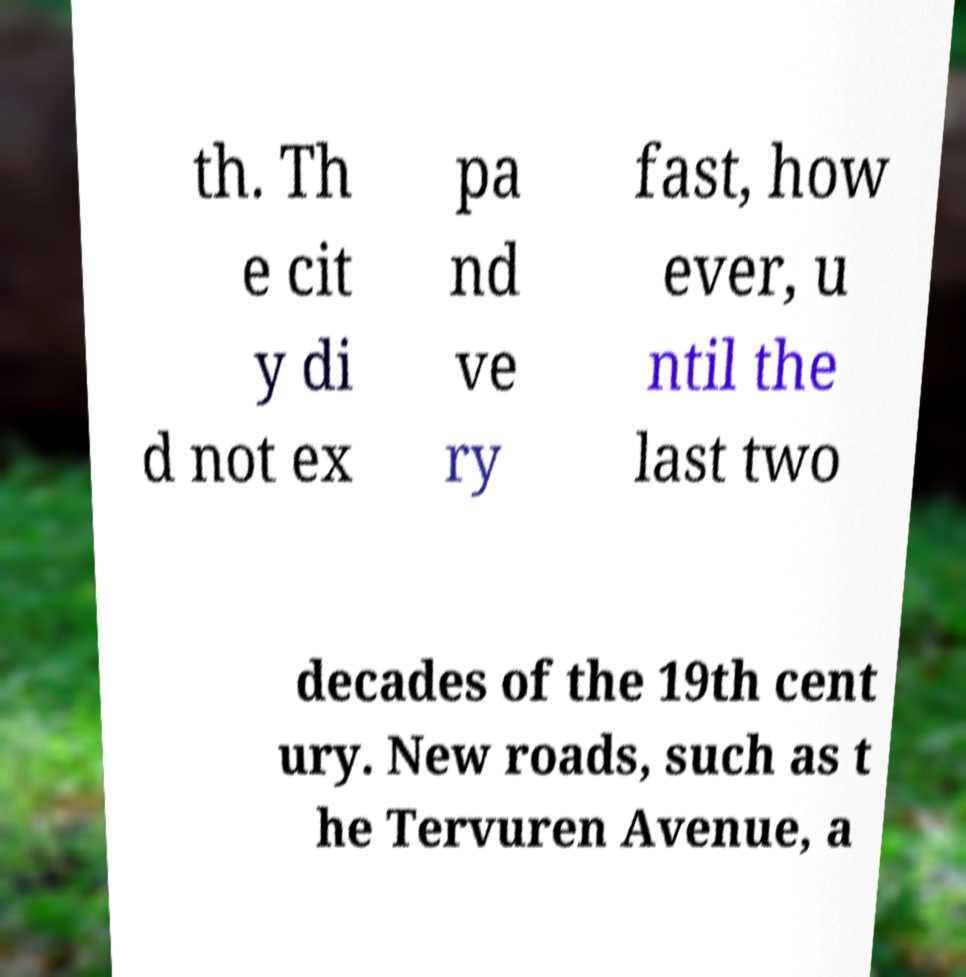For documentation purposes, I need the text within this image transcribed. Could you provide that? th. Th e cit y di d not ex pa nd ve ry fast, how ever, u ntil the last two decades of the 19th cent ury. New roads, such as t he Tervuren Avenue, a 